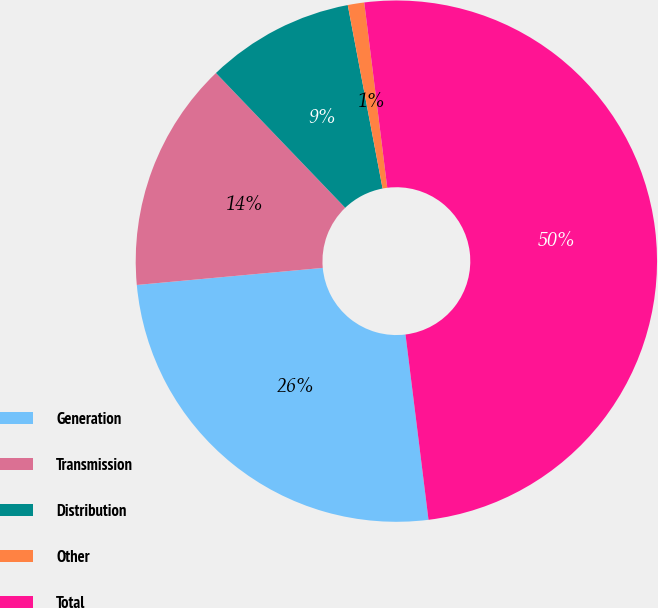<chart> <loc_0><loc_0><loc_500><loc_500><pie_chart><fcel>Generation<fcel>Transmission<fcel>Distribution<fcel>Other<fcel>Total<nl><fcel>25.51%<fcel>14.29%<fcel>9.18%<fcel>1.02%<fcel>50.0%<nl></chart> 